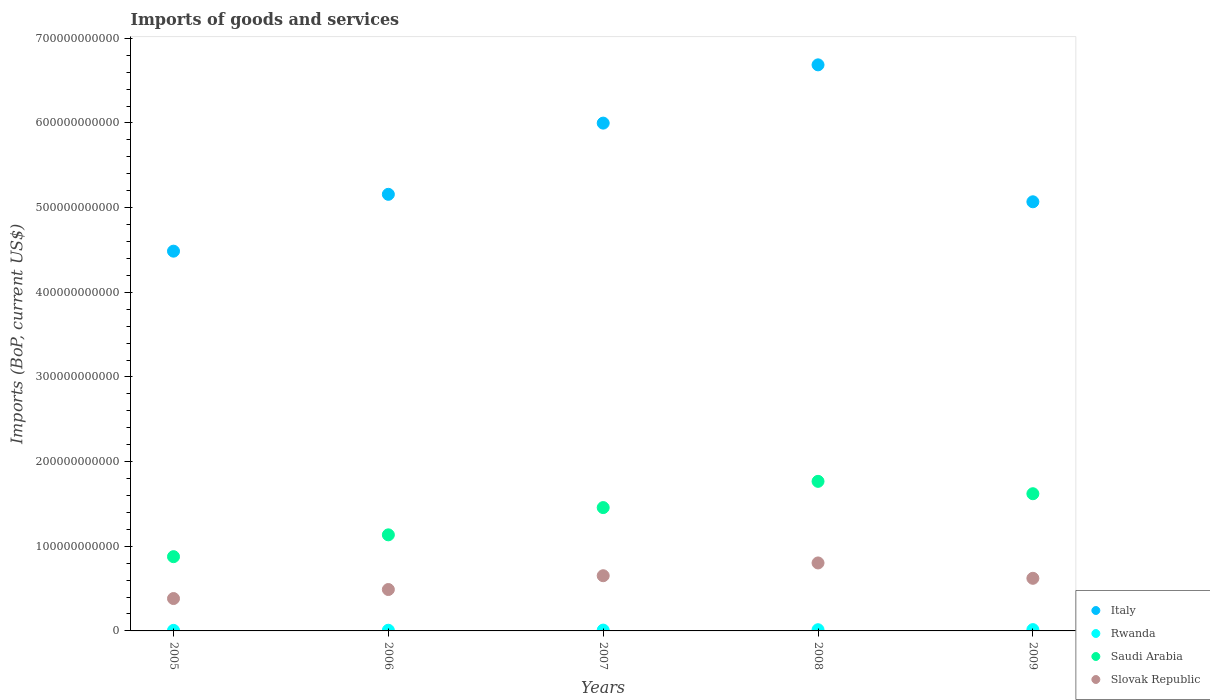How many different coloured dotlines are there?
Keep it short and to the point. 4. Is the number of dotlines equal to the number of legend labels?
Provide a succinct answer. Yes. What is the amount spent on imports in Saudi Arabia in 2008?
Give a very brief answer. 1.77e+11. Across all years, what is the maximum amount spent on imports in Italy?
Your answer should be compact. 6.69e+11. Across all years, what is the minimum amount spent on imports in Rwanda?
Your answer should be very brief. 6.50e+08. In which year was the amount spent on imports in Saudi Arabia minimum?
Your answer should be compact. 2005. What is the total amount spent on imports in Slovak Republic in the graph?
Offer a terse response. 2.95e+11. What is the difference between the amount spent on imports in Rwanda in 2005 and that in 2008?
Make the answer very short. -7.73e+08. What is the difference between the amount spent on imports in Rwanda in 2006 and the amount spent on imports in Italy in 2007?
Keep it short and to the point. -5.99e+11. What is the average amount spent on imports in Saudi Arabia per year?
Provide a short and direct response. 1.37e+11. In the year 2009, what is the difference between the amount spent on imports in Italy and amount spent on imports in Saudi Arabia?
Your answer should be very brief. 3.45e+11. What is the ratio of the amount spent on imports in Saudi Arabia in 2006 to that in 2007?
Offer a terse response. 0.78. Is the difference between the amount spent on imports in Italy in 2005 and 2009 greater than the difference between the amount spent on imports in Saudi Arabia in 2005 and 2009?
Offer a very short reply. Yes. What is the difference between the highest and the second highest amount spent on imports in Saudi Arabia?
Your answer should be very brief. 1.46e+1. What is the difference between the highest and the lowest amount spent on imports in Saudi Arabia?
Offer a terse response. 8.90e+1. What is the difference between two consecutive major ticks on the Y-axis?
Offer a terse response. 1.00e+11. Are the values on the major ticks of Y-axis written in scientific E-notation?
Make the answer very short. No. Does the graph contain grids?
Provide a short and direct response. No. How many legend labels are there?
Keep it short and to the point. 4. How are the legend labels stacked?
Provide a succinct answer. Vertical. What is the title of the graph?
Give a very brief answer. Imports of goods and services. Does "Korea (Republic)" appear as one of the legend labels in the graph?
Keep it short and to the point. No. What is the label or title of the X-axis?
Ensure brevity in your answer.  Years. What is the label or title of the Y-axis?
Make the answer very short. Imports (BoP, current US$). What is the Imports (BoP, current US$) of Italy in 2005?
Offer a terse response. 4.49e+11. What is the Imports (BoP, current US$) in Rwanda in 2005?
Your answer should be very brief. 6.50e+08. What is the Imports (BoP, current US$) in Saudi Arabia in 2005?
Keep it short and to the point. 8.77e+1. What is the Imports (BoP, current US$) of Slovak Republic in 2005?
Make the answer very short. 3.82e+1. What is the Imports (BoP, current US$) in Italy in 2006?
Offer a terse response. 5.16e+11. What is the Imports (BoP, current US$) in Rwanda in 2006?
Keep it short and to the point. 8.07e+08. What is the Imports (BoP, current US$) in Saudi Arabia in 2006?
Offer a very short reply. 1.13e+11. What is the Imports (BoP, current US$) in Slovak Republic in 2006?
Provide a succinct answer. 4.89e+1. What is the Imports (BoP, current US$) in Italy in 2007?
Offer a very short reply. 6.00e+11. What is the Imports (BoP, current US$) in Rwanda in 2007?
Your answer should be compact. 9.68e+08. What is the Imports (BoP, current US$) in Saudi Arabia in 2007?
Provide a succinct answer. 1.46e+11. What is the Imports (BoP, current US$) of Slovak Republic in 2007?
Your answer should be compact. 6.52e+1. What is the Imports (BoP, current US$) in Italy in 2008?
Your answer should be compact. 6.69e+11. What is the Imports (BoP, current US$) in Rwanda in 2008?
Your answer should be very brief. 1.42e+09. What is the Imports (BoP, current US$) of Saudi Arabia in 2008?
Your answer should be very brief. 1.77e+11. What is the Imports (BoP, current US$) of Slovak Republic in 2008?
Provide a short and direct response. 8.03e+1. What is the Imports (BoP, current US$) of Italy in 2009?
Offer a terse response. 5.07e+11. What is the Imports (BoP, current US$) in Rwanda in 2009?
Your answer should be very brief. 1.54e+09. What is the Imports (BoP, current US$) of Saudi Arabia in 2009?
Offer a terse response. 1.62e+11. What is the Imports (BoP, current US$) of Slovak Republic in 2009?
Provide a short and direct response. 6.21e+1. Across all years, what is the maximum Imports (BoP, current US$) of Italy?
Make the answer very short. 6.69e+11. Across all years, what is the maximum Imports (BoP, current US$) of Rwanda?
Ensure brevity in your answer.  1.54e+09. Across all years, what is the maximum Imports (BoP, current US$) of Saudi Arabia?
Offer a terse response. 1.77e+11. Across all years, what is the maximum Imports (BoP, current US$) of Slovak Republic?
Your answer should be compact. 8.03e+1. Across all years, what is the minimum Imports (BoP, current US$) of Italy?
Offer a terse response. 4.49e+11. Across all years, what is the minimum Imports (BoP, current US$) in Rwanda?
Offer a terse response. 6.50e+08. Across all years, what is the minimum Imports (BoP, current US$) of Saudi Arabia?
Your response must be concise. 8.77e+1. Across all years, what is the minimum Imports (BoP, current US$) of Slovak Republic?
Offer a terse response. 3.82e+1. What is the total Imports (BoP, current US$) in Italy in the graph?
Your answer should be compact. 2.74e+12. What is the total Imports (BoP, current US$) of Rwanda in the graph?
Offer a terse response. 5.39e+09. What is the total Imports (BoP, current US$) in Saudi Arabia in the graph?
Your answer should be compact. 6.86e+11. What is the total Imports (BoP, current US$) in Slovak Republic in the graph?
Make the answer very short. 2.95e+11. What is the difference between the Imports (BoP, current US$) of Italy in 2005 and that in 2006?
Keep it short and to the point. -6.72e+1. What is the difference between the Imports (BoP, current US$) in Rwanda in 2005 and that in 2006?
Offer a very short reply. -1.57e+08. What is the difference between the Imports (BoP, current US$) in Saudi Arabia in 2005 and that in 2006?
Ensure brevity in your answer.  -2.58e+1. What is the difference between the Imports (BoP, current US$) of Slovak Republic in 2005 and that in 2006?
Your answer should be compact. -1.07e+1. What is the difference between the Imports (BoP, current US$) in Italy in 2005 and that in 2007?
Offer a terse response. -1.51e+11. What is the difference between the Imports (BoP, current US$) of Rwanda in 2005 and that in 2007?
Offer a terse response. -3.18e+08. What is the difference between the Imports (BoP, current US$) in Saudi Arabia in 2005 and that in 2007?
Make the answer very short. -5.80e+1. What is the difference between the Imports (BoP, current US$) in Slovak Republic in 2005 and that in 2007?
Your answer should be very brief. -2.70e+1. What is the difference between the Imports (BoP, current US$) of Italy in 2005 and that in 2008?
Your response must be concise. -2.20e+11. What is the difference between the Imports (BoP, current US$) in Rwanda in 2005 and that in 2008?
Offer a very short reply. -7.73e+08. What is the difference between the Imports (BoP, current US$) in Saudi Arabia in 2005 and that in 2008?
Your answer should be very brief. -8.90e+1. What is the difference between the Imports (BoP, current US$) in Slovak Republic in 2005 and that in 2008?
Ensure brevity in your answer.  -4.20e+1. What is the difference between the Imports (BoP, current US$) of Italy in 2005 and that in 2009?
Your answer should be very brief. -5.83e+1. What is the difference between the Imports (BoP, current US$) of Rwanda in 2005 and that in 2009?
Offer a very short reply. -8.92e+08. What is the difference between the Imports (BoP, current US$) of Saudi Arabia in 2005 and that in 2009?
Ensure brevity in your answer.  -7.44e+1. What is the difference between the Imports (BoP, current US$) of Slovak Republic in 2005 and that in 2009?
Your answer should be compact. -2.39e+1. What is the difference between the Imports (BoP, current US$) of Italy in 2006 and that in 2007?
Offer a very short reply. -8.41e+1. What is the difference between the Imports (BoP, current US$) in Rwanda in 2006 and that in 2007?
Ensure brevity in your answer.  -1.61e+08. What is the difference between the Imports (BoP, current US$) in Saudi Arabia in 2006 and that in 2007?
Your answer should be compact. -3.22e+1. What is the difference between the Imports (BoP, current US$) of Slovak Republic in 2006 and that in 2007?
Provide a succinct answer. -1.63e+1. What is the difference between the Imports (BoP, current US$) in Italy in 2006 and that in 2008?
Offer a very short reply. -1.53e+11. What is the difference between the Imports (BoP, current US$) in Rwanda in 2006 and that in 2008?
Provide a succinct answer. -6.16e+08. What is the difference between the Imports (BoP, current US$) in Saudi Arabia in 2006 and that in 2008?
Keep it short and to the point. -6.32e+1. What is the difference between the Imports (BoP, current US$) in Slovak Republic in 2006 and that in 2008?
Your answer should be very brief. -3.14e+1. What is the difference between the Imports (BoP, current US$) of Italy in 2006 and that in 2009?
Ensure brevity in your answer.  8.82e+09. What is the difference between the Imports (BoP, current US$) of Rwanda in 2006 and that in 2009?
Provide a succinct answer. -7.35e+08. What is the difference between the Imports (BoP, current US$) in Saudi Arabia in 2006 and that in 2009?
Ensure brevity in your answer.  -4.86e+1. What is the difference between the Imports (BoP, current US$) of Slovak Republic in 2006 and that in 2009?
Provide a succinct answer. -1.32e+1. What is the difference between the Imports (BoP, current US$) in Italy in 2007 and that in 2008?
Ensure brevity in your answer.  -6.88e+1. What is the difference between the Imports (BoP, current US$) in Rwanda in 2007 and that in 2008?
Your answer should be very brief. -4.55e+08. What is the difference between the Imports (BoP, current US$) in Saudi Arabia in 2007 and that in 2008?
Your response must be concise. -3.10e+1. What is the difference between the Imports (BoP, current US$) in Slovak Republic in 2007 and that in 2008?
Your answer should be compact. -1.51e+1. What is the difference between the Imports (BoP, current US$) in Italy in 2007 and that in 2009?
Provide a succinct answer. 9.29e+1. What is the difference between the Imports (BoP, current US$) in Rwanda in 2007 and that in 2009?
Provide a succinct answer. -5.74e+08. What is the difference between the Imports (BoP, current US$) in Saudi Arabia in 2007 and that in 2009?
Your response must be concise. -1.64e+1. What is the difference between the Imports (BoP, current US$) in Slovak Republic in 2007 and that in 2009?
Provide a succinct answer. 3.06e+09. What is the difference between the Imports (BoP, current US$) in Italy in 2008 and that in 2009?
Your response must be concise. 1.62e+11. What is the difference between the Imports (BoP, current US$) of Rwanda in 2008 and that in 2009?
Your answer should be compact. -1.19e+08. What is the difference between the Imports (BoP, current US$) of Saudi Arabia in 2008 and that in 2009?
Offer a terse response. 1.46e+1. What is the difference between the Imports (BoP, current US$) in Slovak Republic in 2008 and that in 2009?
Provide a succinct answer. 1.81e+1. What is the difference between the Imports (BoP, current US$) in Italy in 2005 and the Imports (BoP, current US$) in Rwanda in 2006?
Give a very brief answer. 4.48e+11. What is the difference between the Imports (BoP, current US$) in Italy in 2005 and the Imports (BoP, current US$) in Saudi Arabia in 2006?
Ensure brevity in your answer.  3.35e+11. What is the difference between the Imports (BoP, current US$) of Italy in 2005 and the Imports (BoP, current US$) of Slovak Republic in 2006?
Offer a very short reply. 4.00e+11. What is the difference between the Imports (BoP, current US$) of Rwanda in 2005 and the Imports (BoP, current US$) of Saudi Arabia in 2006?
Make the answer very short. -1.13e+11. What is the difference between the Imports (BoP, current US$) of Rwanda in 2005 and the Imports (BoP, current US$) of Slovak Republic in 2006?
Ensure brevity in your answer.  -4.83e+1. What is the difference between the Imports (BoP, current US$) in Saudi Arabia in 2005 and the Imports (BoP, current US$) in Slovak Republic in 2006?
Your answer should be very brief. 3.88e+1. What is the difference between the Imports (BoP, current US$) in Italy in 2005 and the Imports (BoP, current US$) in Rwanda in 2007?
Your answer should be very brief. 4.48e+11. What is the difference between the Imports (BoP, current US$) of Italy in 2005 and the Imports (BoP, current US$) of Saudi Arabia in 2007?
Your answer should be compact. 3.03e+11. What is the difference between the Imports (BoP, current US$) in Italy in 2005 and the Imports (BoP, current US$) in Slovak Republic in 2007?
Provide a short and direct response. 3.83e+11. What is the difference between the Imports (BoP, current US$) in Rwanda in 2005 and the Imports (BoP, current US$) in Saudi Arabia in 2007?
Your answer should be compact. -1.45e+11. What is the difference between the Imports (BoP, current US$) of Rwanda in 2005 and the Imports (BoP, current US$) of Slovak Republic in 2007?
Keep it short and to the point. -6.46e+1. What is the difference between the Imports (BoP, current US$) of Saudi Arabia in 2005 and the Imports (BoP, current US$) of Slovak Republic in 2007?
Your answer should be very brief. 2.25e+1. What is the difference between the Imports (BoP, current US$) in Italy in 2005 and the Imports (BoP, current US$) in Rwanda in 2008?
Keep it short and to the point. 4.47e+11. What is the difference between the Imports (BoP, current US$) in Italy in 2005 and the Imports (BoP, current US$) in Saudi Arabia in 2008?
Give a very brief answer. 2.72e+11. What is the difference between the Imports (BoP, current US$) of Italy in 2005 and the Imports (BoP, current US$) of Slovak Republic in 2008?
Your answer should be very brief. 3.68e+11. What is the difference between the Imports (BoP, current US$) in Rwanda in 2005 and the Imports (BoP, current US$) in Saudi Arabia in 2008?
Keep it short and to the point. -1.76e+11. What is the difference between the Imports (BoP, current US$) of Rwanda in 2005 and the Imports (BoP, current US$) of Slovak Republic in 2008?
Give a very brief answer. -7.96e+1. What is the difference between the Imports (BoP, current US$) of Saudi Arabia in 2005 and the Imports (BoP, current US$) of Slovak Republic in 2008?
Offer a very short reply. 7.42e+09. What is the difference between the Imports (BoP, current US$) in Italy in 2005 and the Imports (BoP, current US$) in Rwanda in 2009?
Your answer should be very brief. 4.47e+11. What is the difference between the Imports (BoP, current US$) of Italy in 2005 and the Imports (BoP, current US$) of Saudi Arabia in 2009?
Your response must be concise. 2.87e+11. What is the difference between the Imports (BoP, current US$) of Italy in 2005 and the Imports (BoP, current US$) of Slovak Republic in 2009?
Keep it short and to the point. 3.86e+11. What is the difference between the Imports (BoP, current US$) in Rwanda in 2005 and the Imports (BoP, current US$) in Saudi Arabia in 2009?
Offer a terse response. -1.61e+11. What is the difference between the Imports (BoP, current US$) in Rwanda in 2005 and the Imports (BoP, current US$) in Slovak Republic in 2009?
Offer a terse response. -6.15e+1. What is the difference between the Imports (BoP, current US$) of Saudi Arabia in 2005 and the Imports (BoP, current US$) of Slovak Republic in 2009?
Provide a short and direct response. 2.56e+1. What is the difference between the Imports (BoP, current US$) of Italy in 2006 and the Imports (BoP, current US$) of Rwanda in 2007?
Provide a short and direct response. 5.15e+11. What is the difference between the Imports (BoP, current US$) in Italy in 2006 and the Imports (BoP, current US$) in Saudi Arabia in 2007?
Your answer should be very brief. 3.70e+11. What is the difference between the Imports (BoP, current US$) in Italy in 2006 and the Imports (BoP, current US$) in Slovak Republic in 2007?
Your response must be concise. 4.51e+11. What is the difference between the Imports (BoP, current US$) in Rwanda in 2006 and the Imports (BoP, current US$) in Saudi Arabia in 2007?
Provide a succinct answer. -1.45e+11. What is the difference between the Imports (BoP, current US$) of Rwanda in 2006 and the Imports (BoP, current US$) of Slovak Republic in 2007?
Keep it short and to the point. -6.44e+1. What is the difference between the Imports (BoP, current US$) in Saudi Arabia in 2006 and the Imports (BoP, current US$) in Slovak Republic in 2007?
Ensure brevity in your answer.  4.83e+1. What is the difference between the Imports (BoP, current US$) of Italy in 2006 and the Imports (BoP, current US$) of Rwanda in 2008?
Provide a succinct answer. 5.14e+11. What is the difference between the Imports (BoP, current US$) of Italy in 2006 and the Imports (BoP, current US$) of Saudi Arabia in 2008?
Provide a succinct answer. 3.39e+11. What is the difference between the Imports (BoP, current US$) of Italy in 2006 and the Imports (BoP, current US$) of Slovak Republic in 2008?
Ensure brevity in your answer.  4.35e+11. What is the difference between the Imports (BoP, current US$) of Rwanda in 2006 and the Imports (BoP, current US$) of Saudi Arabia in 2008?
Make the answer very short. -1.76e+11. What is the difference between the Imports (BoP, current US$) in Rwanda in 2006 and the Imports (BoP, current US$) in Slovak Republic in 2008?
Your answer should be compact. -7.95e+1. What is the difference between the Imports (BoP, current US$) of Saudi Arabia in 2006 and the Imports (BoP, current US$) of Slovak Republic in 2008?
Give a very brief answer. 3.32e+1. What is the difference between the Imports (BoP, current US$) in Italy in 2006 and the Imports (BoP, current US$) in Rwanda in 2009?
Keep it short and to the point. 5.14e+11. What is the difference between the Imports (BoP, current US$) in Italy in 2006 and the Imports (BoP, current US$) in Saudi Arabia in 2009?
Give a very brief answer. 3.54e+11. What is the difference between the Imports (BoP, current US$) in Italy in 2006 and the Imports (BoP, current US$) in Slovak Republic in 2009?
Give a very brief answer. 4.54e+11. What is the difference between the Imports (BoP, current US$) of Rwanda in 2006 and the Imports (BoP, current US$) of Saudi Arabia in 2009?
Ensure brevity in your answer.  -1.61e+11. What is the difference between the Imports (BoP, current US$) in Rwanda in 2006 and the Imports (BoP, current US$) in Slovak Republic in 2009?
Provide a succinct answer. -6.13e+1. What is the difference between the Imports (BoP, current US$) in Saudi Arabia in 2006 and the Imports (BoP, current US$) in Slovak Republic in 2009?
Offer a very short reply. 5.13e+1. What is the difference between the Imports (BoP, current US$) in Italy in 2007 and the Imports (BoP, current US$) in Rwanda in 2008?
Your response must be concise. 5.98e+11. What is the difference between the Imports (BoP, current US$) in Italy in 2007 and the Imports (BoP, current US$) in Saudi Arabia in 2008?
Provide a succinct answer. 4.23e+11. What is the difference between the Imports (BoP, current US$) in Italy in 2007 and the Imports (BoP, current US$) in Slovak Republic in 2008?
Your response must be concise. 5.20e+11. What is the difference between the Imports (BoP, current US$) in Rwanda in 2007 and the Imports (BoP, current US$) in Saudi Arabia in 2008?
Keep it short and to the point. -1.76e+11. What is the difference between the Imports (BoP, current US$) of Rwanda in 2007 and the Imports (BoP, current US$) of Slovak Republic in 2008?
Your answer should be compact. -7.93e+1. What is the difference between the Imports (BoP, current US$) in Saudi Arabia in 2007 and the Imports (BoP, current US$) in Slovak Republic in 2008?
Offer a terse response. 6.54e+1. What is the difference between the Imports (BoP, current US$) in Italy in 2007 and the Imports (BoP, current US$) in Rwanda in 2009?
Make the answer very short. 5.98e+11. What is the difference between the Imports (BoP, current US$) in Italy in 2007 and the Imports (BoP, current US$) in Saudi Arabia in 2009?
Give a very brief answer. 4.38e+11. What is the difference between the Imports (BoP, current US$) in Italy in 2007 and the Imports (BoP, current US$) in Slovak Republic in 2009?
Provide a short and direct response. 5.38e+11. What is the difference between the Imports (BoP, current US$) in Rwanda in 2007 and the Imports (BoP, current US$) in Saudi Arabia in 2009?
Keep it short and to the point. -1.61e+11. What is the difference between the Imports (BoP, current US$) in Rwanda in 2007 and the Imports (BoP, current US$) in Slovak Republic in 2009?
Give a very brief answer. -6.12e+1. What is the difference between the Imports (BoP, current US$) in Saudi Arabia in 2007 and the Imports (BoP, current US$) in Slovak Republic in 2009?
Give a very brief answer. 8.35e+1. What is the difference between the Imports (BoP, current US$) of Italy in 2008 and the Imports (BoP, current US$) of Rwanda in 2009?
Your response must be concise. 6.67e+11. What is the difference between the Imports (BoP, current US$) in Italy in 2008 and the Imports (BoP, current US$) in Saudi Arabia in 2009?
Provide a succinct answer. 5.07e+11. What is the difference between the Imports (BoP, current US$) in Italy in 2008 and the Imports (BoP, current US$) in Slovak Republic in 2009?
Your answer should be compact. 6.07e+11. What is the difference between the Imports (BoP, current US$) of Rwanda in 2008 and the Imports (BoP, current US$) of Saudi Arabia in 2009?
Offer a terse response. -1.61e+11. What is the difference between the Imports (BoP, current US$) of Rwanda in 2008 and the Imports (BoP, current US$) of Slovak Republic in 2009?
Offer a very short reply. -6.07e+1. What is the difference between the Imports (BoP, current US$) in Saudi Arabia in 2008 and the Imports (BoP, current US$) in Slovak Republic in 2009?
Offer a terse response. 1.15e+11. What is the average Imports (BoP, current US$) of Italy per year?
Your answer should be very brief. 5.48e+11. What is the average Imports (BoP, current US$) in Rwanda per year?
Your response must be concise. 1.08e+09. What is the average Imports (BoP, current US$) of Saudi Arabia per year?
Provide a short and direct response. 1.37e+11. What is the average Imports (BoP, current US$) of Slovak Republic per year?
Make the answer very short. 5.90e+1. In the year 2005, what is the difference between the Imports (BoP, current US$) of Italy and Imports (BoP, current US$) of Rwanda?
Provide a succinct answer. 4.48e+11. In the year 2005, what is the difference between the Imports (BoP, current US$) in Italy and Imports (BoP, current US$) in Saudi Arabia?
Your response must be concise. 3.61e+11. In the year 2005, what is the difference between the Imports (BoP, current US$) of Italy and Imports (BoP, current US$) of Slovak Republic?
Keep it short and to the point. 4.10e+11. In the year 2005, what is the difference between the Imports (BoP, current US$) of Rwanda and Imports (BoP, current US$) of Saudi Arabia?
Offer a very short reply. -8.71e+1. In the year 2005, what is the difference between the Imports (BoP, current US$) in Rwanda and Imports (BoP, current US$) in Slovak Republic?
Give a very brief answer. -3.76e+1. In the year 2005, what is the difference between the Imports (BoP, current US$) of Saudi Arabia and Imports (BoP, current US$) of Slovak Republic?
Keep it short and to the point. 4.95e+1. In the year 2006, what is the difference between the Imports (BoP, current US$) in Italy and Imports (BoP, current US$) in Rwanda?
Keep it short and to the point. 5.15e+11. In the year 2006, what is the difference between the Imports (BoP, current US$) of Italy and Imports (BoP, current US$) of Saudi Arabia?
Offer a terse response. 4.02e+11. In the year 2006, what is the difference between the Imports (BoP, current US$) of Italy and Imports (BoP, current US$) of Slovak Republic?
Provide a succinct answer. 4.67e+11. In the year 2006, what is the difference between the Imports (BoP, current US$) in Rwanda and Imports (BoP, current US$) in Saudi Arabia?
Your answer should be compact. -1.13e+11. In the year 2006, what is the difference between the Imports (BoP, current US$) of Rwanda and Imports (BoP, current US$) of Slovak Republic?
Your answer should be compact. -4.81e+1. In the year 2006, what is the difference between the Imports (BoP, current US$) of Saudi Arabia and Imports (BoP, current US$) of Slovak Republic?
Offer a very short reply. 6.46e+1. In the year 2007, what is the difference between the Imports (BoP, current US$) of Italy and Imports (BoP, current US$) of Rwanda?
Ensure brevity in your answer.  5.99e+11. In the year 2007, what is the difference between the Imports (BoP, current US$) in Italy and Imports (BoP, current US$) in Saudi Arabia?
Provide a short and direct response. 4.54e+11. In the year 2007, what is the difference between the Imports (BoP, current US$) of Italy and Imports (BoP, current US$) of Slovak Republic?
Provide a short and direct response. 5.35e+11. In the year 2007, what is the difference between the Imports (BoP, current US$) in Rwanda and Imports (BoP, current US$) in Saudi Arabia?
Your answer should be very brief. -1.45e+11. In the year 2007, what is the difference between the Imports (BoP, current US$) of Rwanda and Imports (BoP, current US$) of Slovak Republic?
Provide a short and direct response. -6.42e+1. In the year 2007, what is the difference between the Imports (BoP, current US$) in Saudi Arabia and Imports (BoP, current US$) in Slovak Republic?
Your response must be concise. 8.05e+1. In the year 2008, what is the difference between the Imports (BoP, current US$) of Italy and Imports (BoP, current US$) of Rwanda?
Make the answer very short. 6.67e+11. In the year 2008, what is the difference between the Imports (BoP, current US$) in Italy and Imports (BoP, current US$) in Saudi Arabia?
Your answer should be compact. 4.92e+11. In the year 2008, what is the difference between the Imports (BoP, current US$) of Italy and Imports (BoP, current US$) of Slovak Republic?
Your answer should be compact. 5.88e+11. In the year 2008, what is the difference between the Imports (BoP, current US$) of Rwanda and Imports (BoP, current US$) of Saudi Arabia?
Provide a succinct answer. -1.75e+11. In the year 2008, what is the difference between the Imports (BoP, current US$) of Rwanda and Imports (BoP, current US$) of Slovak Republic?
Provide a short and direct response. -7.89e+1. In the year 2008, what is the difference between the Imports (BoP, current US$) of Saudi Arabia and Imports (BoP, current US$) of Slovak Republic?
Offer a very short reply. 9.64e+1. In the year 2009, what is the difference between the Imports (BoP, current US$) in Italy and Imports (BoP, current US$) in Rwanda?
Your answer should be very brief. 5.05e+11. In the year 2009, what is the difference between the Imports (BoP, current US$) in Italy and Imports (BoP, current US$) in Saudi Arabia?
Provide a short and direct response. 3.45e+11. In the year 2009, what is the difference between the Imports (BoP, current US$) of Italy and Imports (BoP, current US$) of Slovak Republic?
Your answer should be very brief. 4.45e+11. In the year 2009, what is the difference between the Imports (BoP, current US$) of Rwanda and Imports (BoP, current US$) of Saudi Arabia?
Ensure brevity in your answer.  -1.61e+11. In the year 2009, what is the difference between the Imports (BoP, current US$) in Rwanda and Imports (BoP, current US$) in Slovak Republic?
Offer a very short reply. -6.06e+1. In the year 2009, what is the difference between the Imports (BoP, current US$) of Saudi Arabia and Imports (BoP, current US$) of Slovak Republic?
Provide a short and direct response. 9.99e+1. What is the ratio of the Imports (BoP, current US$) of Italy in 2005 to that in 2006?
Your answer should be compact. 0.87. What is the ratio of the Imports (BoP, current US$) in Rwanda in 2005 to that in 2006?
Keep it short and to the point. 0.81. What is the ratio of the Imports (BoP, current US$) of Saudi Arabia in 2005 to that in 2006?
Your answer should be compact. 0.77. What is the ratio of the Imports (BoP, current US$) of Slovak Republic in 2005 to that in 2006?
Give a very brief answer. 0.78. What is the ratio of the Imports (BoP, current US$) in Italy in 2005 to that in 2007?
Your answer should be very brief. 0.75. What is the ratio of the Imports (BoP, current US$) in Rwanda in 2005 to that in 2007?
Provide a short and direct response. 0.67. What is the ratio of the Imports (BoP, current US$) in Saudi Arabia in 2005 to that in 2007?
Offer a very short reply. 0.6. What is the ratio of the Imports (BoP, current US$) in Slovak Republic in 2005 to that in 2007?
Ensure brevity in your answer.  0.59. What is the ratio of the Imports (BoP, current US$) in Italy in 2005 to that in 2008?
Offer a terse response. 0.67. What is the ratio of the Imports (BoP, current US$) of Rwanda in 2005 to that in 2008?
Give a very brief answer. 0.46. What is the ratio of the Imports (BoP, current US$) of Saudi Arabia in 2005 to that in 2008?
Make the answer very short. 0.5. What is the ratio of the Imports (BoP, current US$) of Slovak Republic in 2005 to that in 2008?
Give a very brief answer. 0.48. What is the ratio of the Imports (BoP, current US$) of Italy in 2005 to that in 2009?
Give a very brief answer. 0.88. What is the ratio of the Imports (BoP, current US$) of Rwanda in 2005 to that in 2009?
Your answer should be compact. 0.42. What is the ratio of the Imports (BoP, current US$) of Saudi Arabia in 2005 to that in 2009?
Provide a succinct answer. 0.54. What is the ratio of the Imports (BoP, current US$) of Slovak Republic in 2005 to that in 2009?
Offer a very short reply. 0.62. What is the ratio of the Imports (BoP, current US$) of Italy in 2006 to that in 2007?
Your response must be concise. 0.86. What is the ratio of the Imports (BoP, current US$) of Rwanda in 2006 to that in 2007?
Ensure brevity in your answer.  0.83. What is the ratio of the Imports (BoP, current US$) of Saudi Arabia in 2006 to that in 2007?
Your response must be concise. 0.78. What is the ratio of the Imports (BoP, current US$) of Italy in 2006 to that in 2008?
Keep it short and to the point. 0.77. What is the ratio of the Imports (BoP, current US$) in Rwanda in 2006 to that in 2008?
Offer a very short reply. 0.57. What is the ratio of the Imports (BoP, current US$) of Saudi Arabia in 2006 to that in 2008?
Provide a short and direct response. 0.64. What is the ratio of the Imports (BoP, current US$) in Slovak Republic in 2006 to that in 2008?
Ensure brevity in your answer.  0.61. What is the ratio of the Imports (BoP, current US$) of Italy in 2006 to that in 2009?
Give a very brief answer. 1.02. What is the ratio of the Imports (BoP, current US$) in Rwanda in 2006 to that in 2009?
Keep it short and to the point. 0.52. What is the ratio of the Imports (BoP, current US$) of Saudi Arabia in 2006 to that in 2009?
Your answer should be compact. 0.7. What is the ratio of the Imports (BoP, current US$) of Slovak Republic in 2006 to that in 2009?
Offer a terse response. 0.79. What is the ratio of the Imports (BoP, current US$) in Italy in 2007 to that in 2008?
Ensure brevity in your answer.  0.9. What is the ratio of the Imports (BoP, current US$) of Rwanda in 2007 to that in 2008?
Offer a terse response. 0.68. What is the ratio of the Imports (BoP, current US$) in Saudi Arabia in 2007 to that in 2008?
Your answer should be very brief. 0.82. What is the ratio of the Imports (BoP, current US$) of Slovak Republic in 2007 to that in 2008?
Ensure brevity in your answer.  0.81. What is the ratio of the Imports (BoP, current US$) in Italy in 2007 to that in 2009?
Provide a short and direct response. 1.18. What is the ratio of the Imports (BoP, current US$) in Rwanda in 2007 to that in 2009?
Make the answer very short. 0.63. What is the ratio of the Imports (BoP, current US$) in Saudi Arabia in 2007 to that in 2009?
Give a very brief answer. 0.9. What is the ratio of the Imports (BoP, current US$) of Slovak Republic in 2007 to that in 2009?
Offer a terse response. 1.05. What is the ratio of the Imports (BoP, current US$) of Italy in 2008 to that in 2009?
Keep it short and to the point. 1.32. What is the ratio of the Imports (BoP, current US$) of Rwanda in 2008 to that in 2009?
Provide a succinct answer. 0.92. What is the ratio of the Imports (BoP, current US$) of Saudi Arabia in 2008 to that in 2009?
Offer a very short reply. 1.09. What is the ratio of the Imports (BoP, current US$) in Slovak Republic in 2008 to that in 2009?
Your response must be concise. 1.29. What is the difference between the highest and the second highest Imports (BoP, current US$) in Italy?
Offer a very short reply. 6.88e+1. What is the difference between the highest and the second highest Imports (BoP, current US$) in Rwanda?
Provide a succinct answer. 1.19e+08. What is the difference between the highest and the second highest Imports (BoP, current US$) of Saudi Arabia?
Provide a succinct answer. 1.46e+1. What is the difference between the highest and the second highest Imports (BoP, current US$) in Slovak Republic?
Make the answer very short. 1.51e+1. What is the difference between the highest and the lowest Imports (BoP, current US$) in Italy?
Keep it short and to the point. 2.20e+11. What is the difference between the highest and the lowest Imports (BoP, current US$) in Rwanda?
Offer a terse response. 8.92e+08. What is the difference between the highest and the lowest Imports (BoP, current US$) of Saudi Arabia?
Offer a very short reply. 8.90e+1. What is the difference between the highest and the lowest Imports (BoP, current US$) of Slovak Republic?
Ensure brevity in your answer.  4.20e+1. 